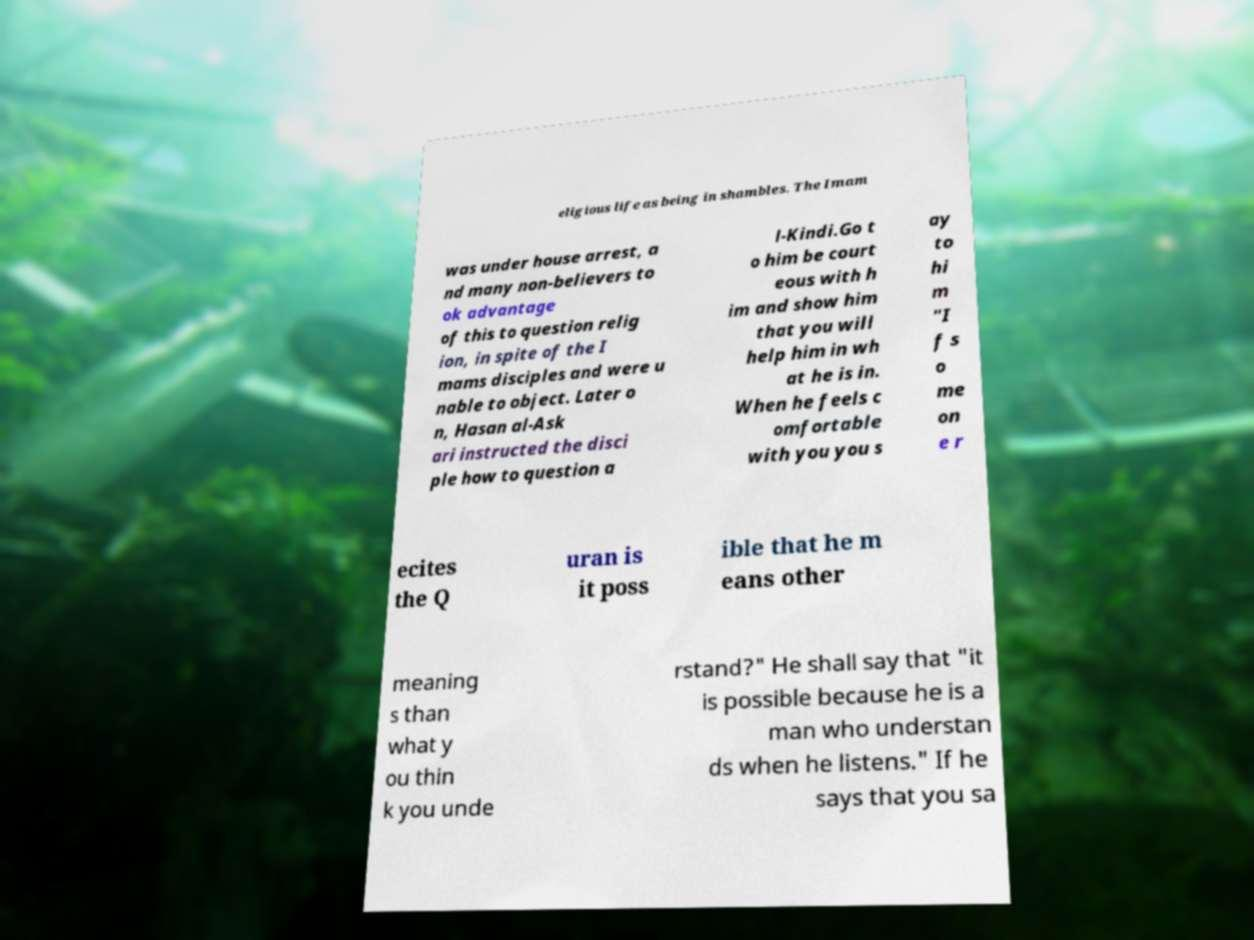What messages or text are displayed in this image? I need them in a readable, typed format. eligious life as being in shambles. The Imam was under house arrest, a nd many non-believers to ok advantage of this to question relig ion, in spite of the I mams disciples and were u nable to object. Later o n, Hasan al-Ask ari instructed the disci ple how to question a l-Kindi.Go t o him be court eous with h im and show him that you will help him in wh at he is in. When he feels c omfortable with you you s ay to hi m "I f s o me on e r ecites the Q uran is it poss ible that he m eans other meaning s than what y ou thin k you unde rstand?" He shall say that "it is possible because he is a man who understan ds when he listens." If he says that you sa 